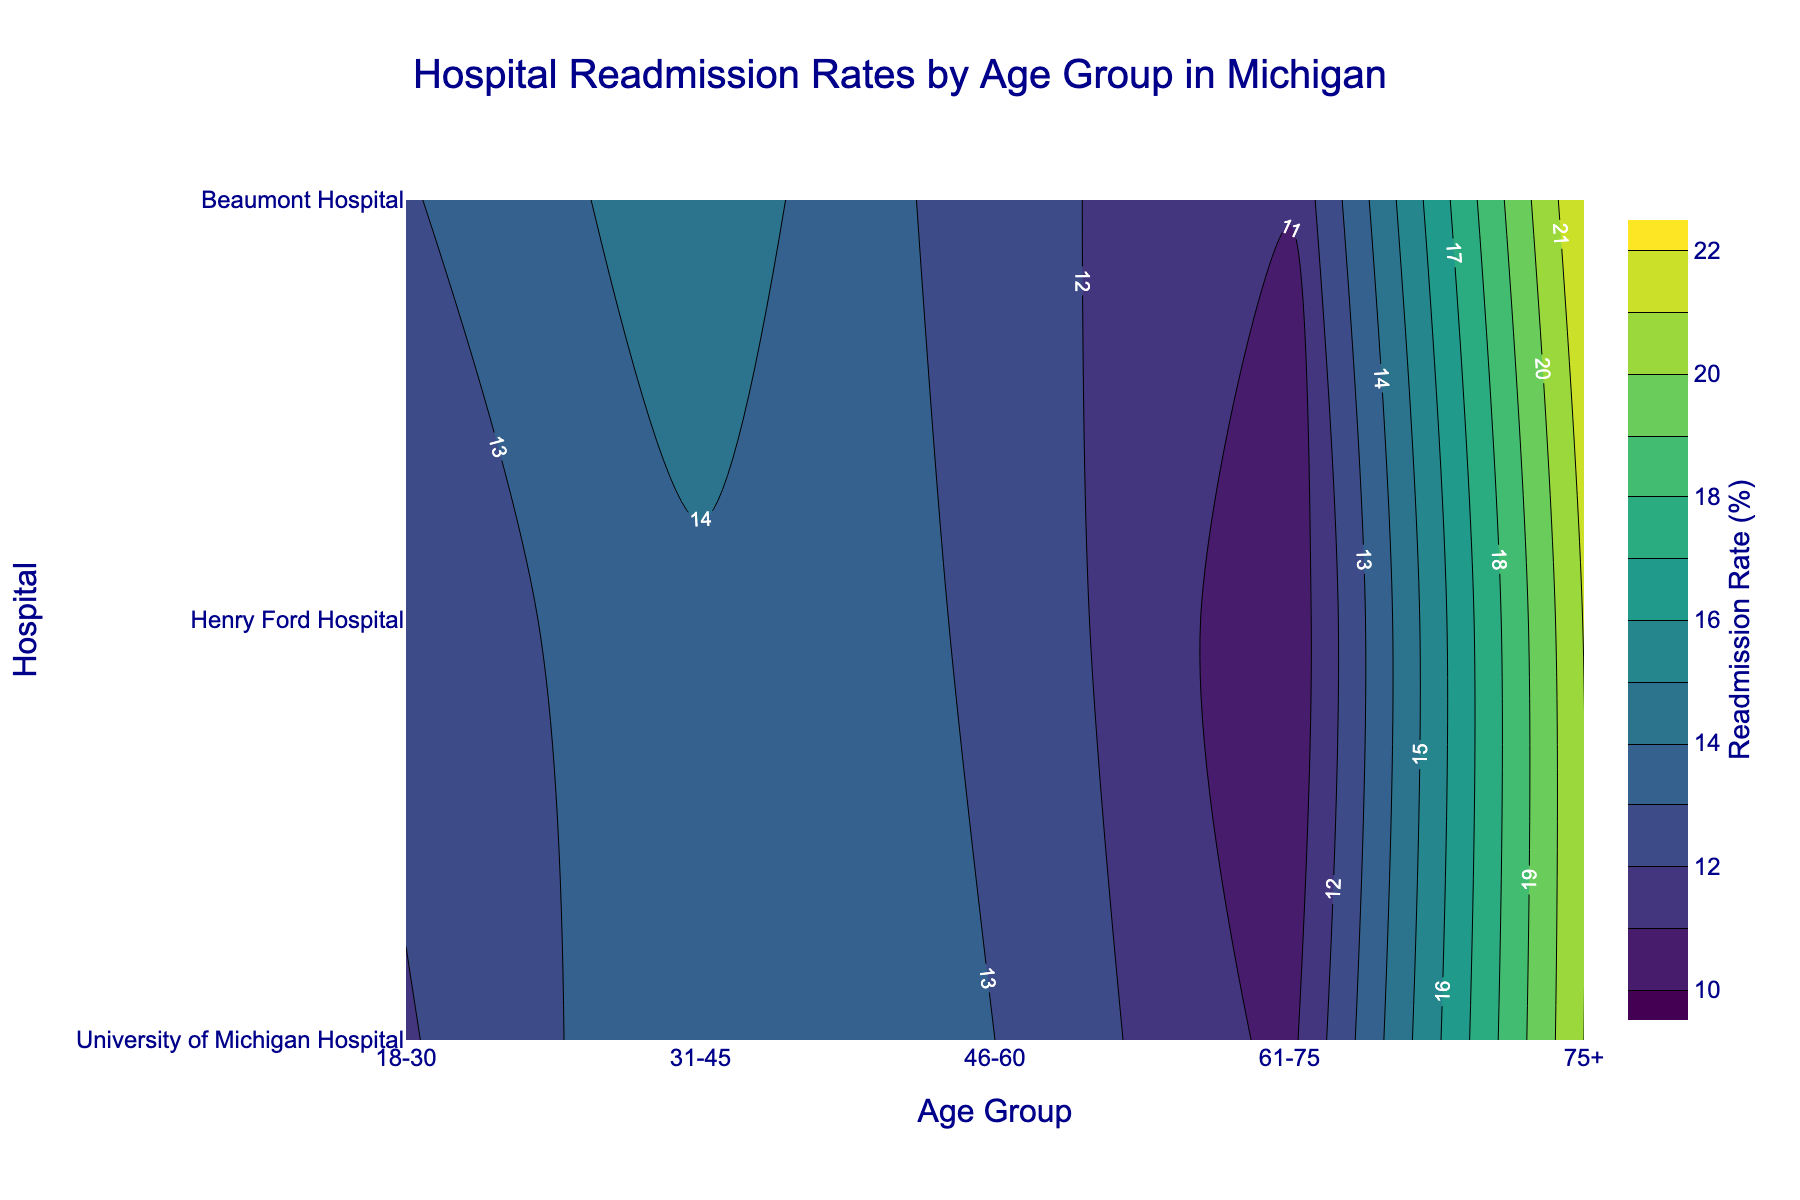Which age group has the highest readmission rate for University of Michigan Hospital? From the contour plot, we can identify that the highest readmission rate at University of Michigan Hospital occurs in the age group labeled with the deepest color, which corresponds to age group 75+.
Answer: 75+ What is the range of readmission rates illustrated in the contour plot? The contour plot legend indicates that the readmission rates range from 10% to 22%, as these are the labeled limits of the color gradient.
Answer: 10% to 22% How does the readmission rate for age group 31-45 at Henry Ford Hospital compare to the age group 46-60 at the same hospital? The readmission rate for age group 31-45 at Henry Ford Hospital can be observed from the contour plot as higher in color intensity than age group 46-60, indicating a higher readmission rate. By comparing the colors, age group 31-45 has a darker color.
Answer: Age group 31-45 has a higher readmission rate than age group 46-60 What can be inferred about the readmission rates for Asian patients across all hospitals? Looking at the plots for age groups 61-75 for all hospitals, the contour colors are relatively lighter compared to other age groups, which implies lower readmission rates for Asian patients overall.
Answer: Lower readmission rates Which hospital has the most consistent readmission rates across all age groups? To determine consistency, observe the contour plot to see which hospital's contour lines are closest together and show minimal variation in color intensity. Henry Ford Hospital's contours are closer and show less drastic color changes, suggesting more consistency.
Answer: Henry Ford Hospital Which hospital and age group combination have the highest readmission rate? From the contour plot, look for the darkest color which indicates the highest readmission rate. This combination is found at Beaumont Hospital for the age group 75+.
Answer: Beaumont Hospital, age group 75+ What is the readmission rate difference between the oldest and youngest age groups at Beaumont Hospital? From the contour plot, identify the average readmission rate for the oldest (75+) and youngest (18-30) at Beaumont Hospital. The oldest group (75+) has a darker color corresponding to around 22%, while the youngest group (18-30) has a color around 13%. The difference is 22% - 13% = 9%.
Answer: 9% What age group shows the most variation in readmission rates across all hospitals? To determine this, observe the spread and color intensity differences for each age group across all hospital sections. The 75+ age group shows the widest color range (from lighter to darkest color), indicating the most variation.
Answer: 75+ How does the readmission rate for the age group 61-75 at University of Michigan Hospital compare to Henry Ford Hospital? Compare the contour colors for the 61-75 age group at both hospitals. University of Michigan Hospital shows a slightly darker contour color for 61-75 age group, indicating a higher readmission rate compared to Henry Ford Hospital, which has a slightly lighter color.
Answer: University of Michigan Hospital has a higher readmission rate What can you infer about the readmission rate trends from age group 18-30 to 75+ at Beaumont Hospital? By examining the color gradient intensities in the contour plot for each age group at Beaumont Hospital, we can see a gradual increase in darkness from 18-30 to 75+, demonstrating an upward trend in readmission rates with increasing age.
Answer: Increasing trend 